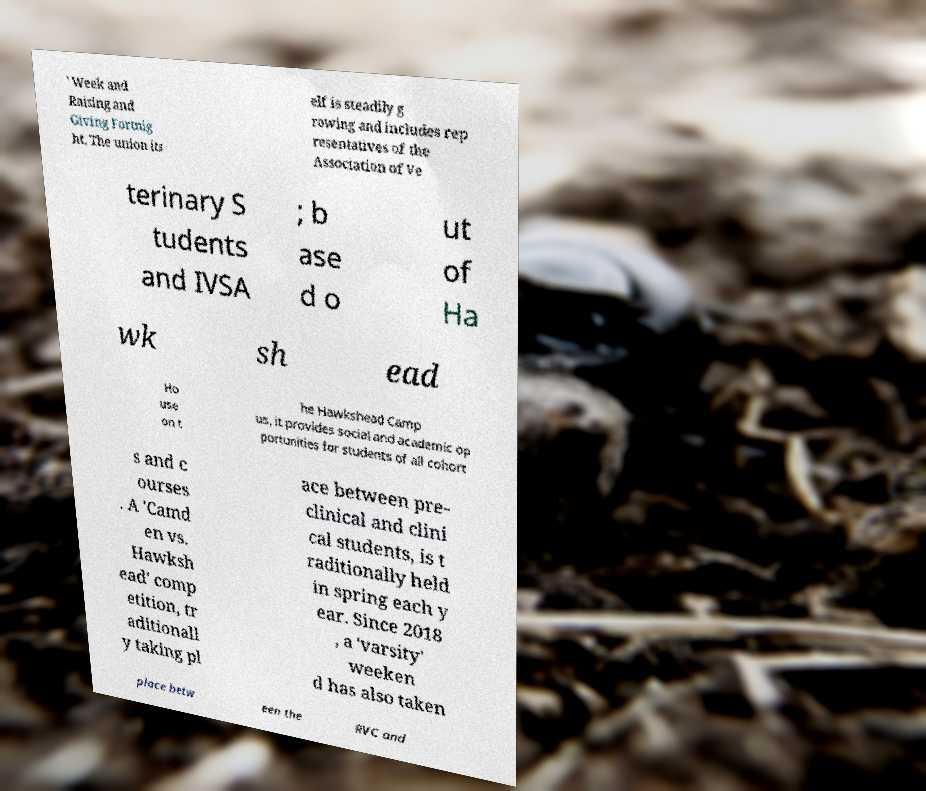There's text embedded in this image that I need extracted. Can you transcribe it verbatim? ' Week and Raising and Giving Fortnig ht. The union its elf is steadily g rowing and includes rep resentatives of the Association of Ve terinary S tudents and IVSA ; b ase d o ut of Ha wk sh ead Ho use on t he Hawkshead Camp us, it provides social and academic op portunities for students of all cohort s and c ourses . A 'Camd en vs. Hawksh ead' comp etition, tr aditionall y taking pl ace between pre- clinical and clini cal students, is t raditionally held in spring each y ear. Since 2018 , a 'varsity' weeken d has also taken place betw een the RVC and 